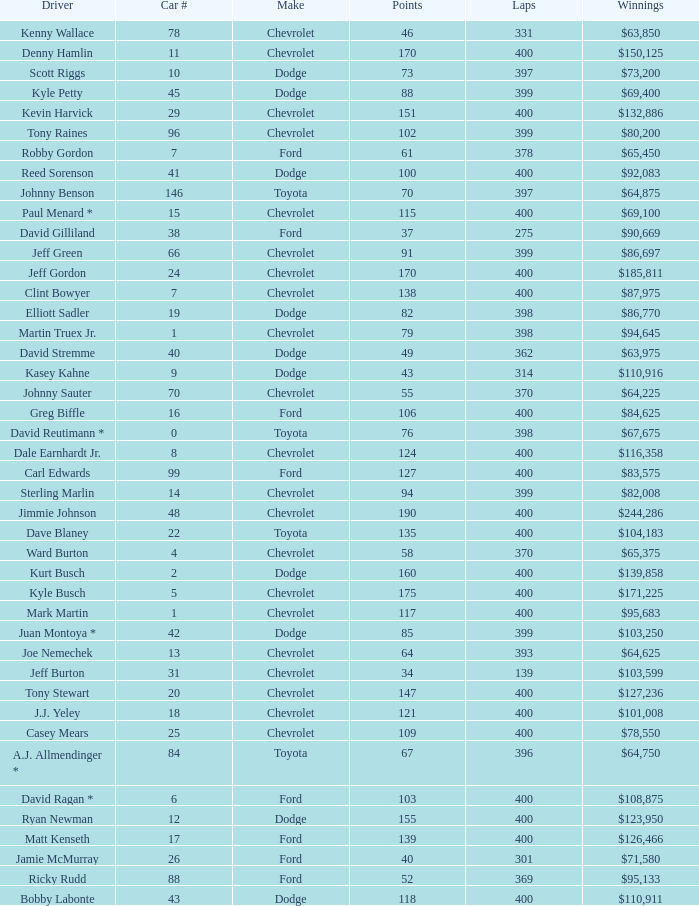What is the make of car 31? Chevrolet. 